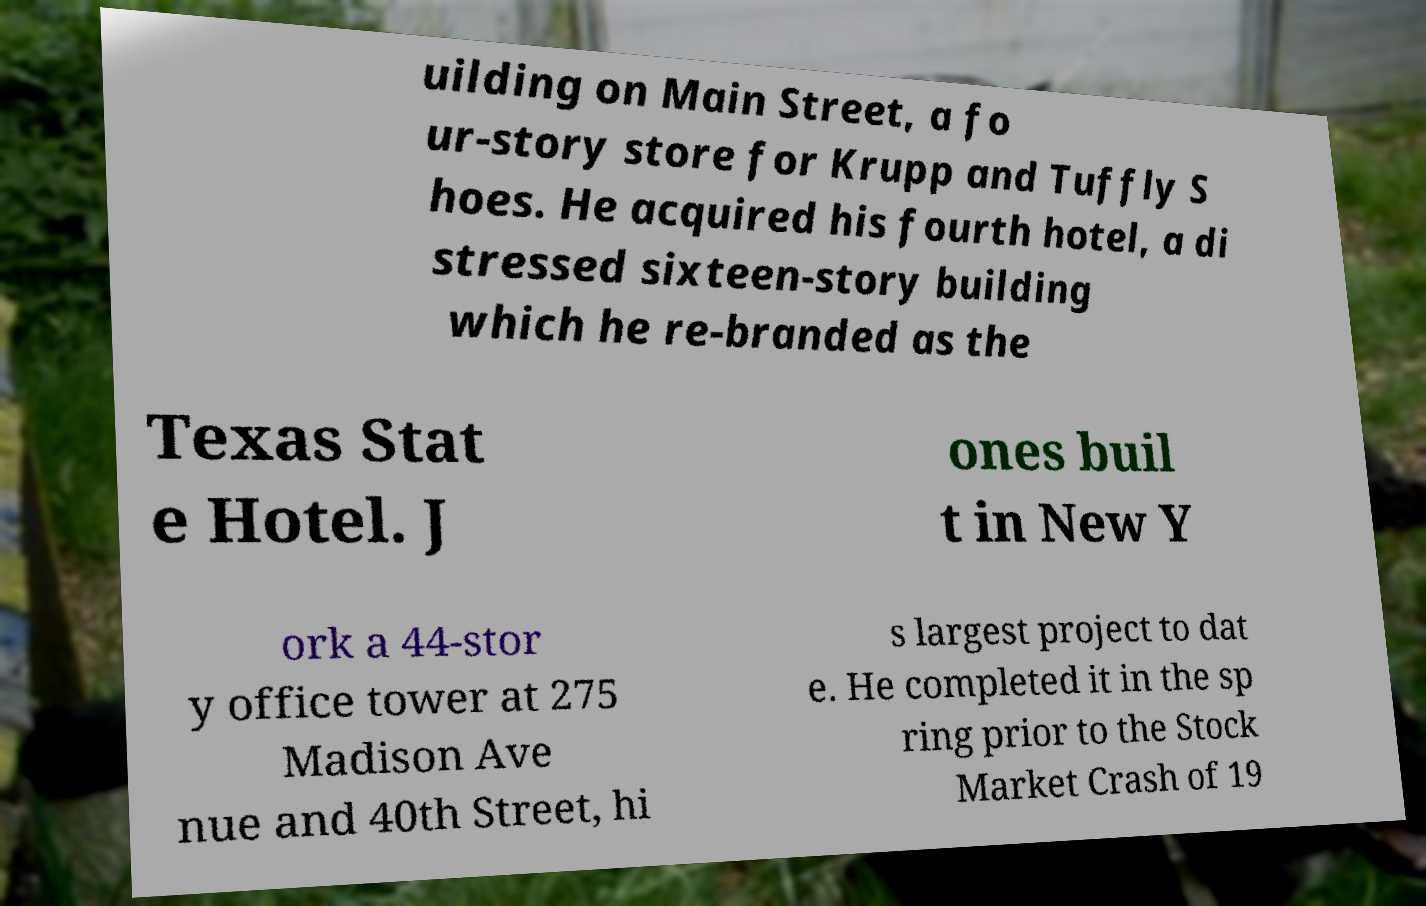Can you read and provide the text displayed in the image?This photo seems to have some interesting text. Can you extract and type it out for me? uilding on Main Street, a fo ur-story store for Krupp and Tuffly S hoes. He acquired his fourth hotel, a di stressed sixteen-story building which he re-branded as the Texas Stat e Hotel. J ones buil t in New Y ork a 44-stor y office tower at 275 Madison Ave nue and 40th Street, hi s largest project to dat e. He completed it in the sp ring prior to the Stock Market Crash of 19 